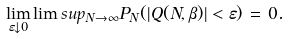<formula> <loc_0><loc_0><loc_500><loc_500>\lim _ { \varepsilon \downarrow 0 } \lim s u p _ { N \to \infty } { P } _ { N } ( | Q ( N , \beta ) | < \varepsilon ) \, = \, 0 .</formula> 